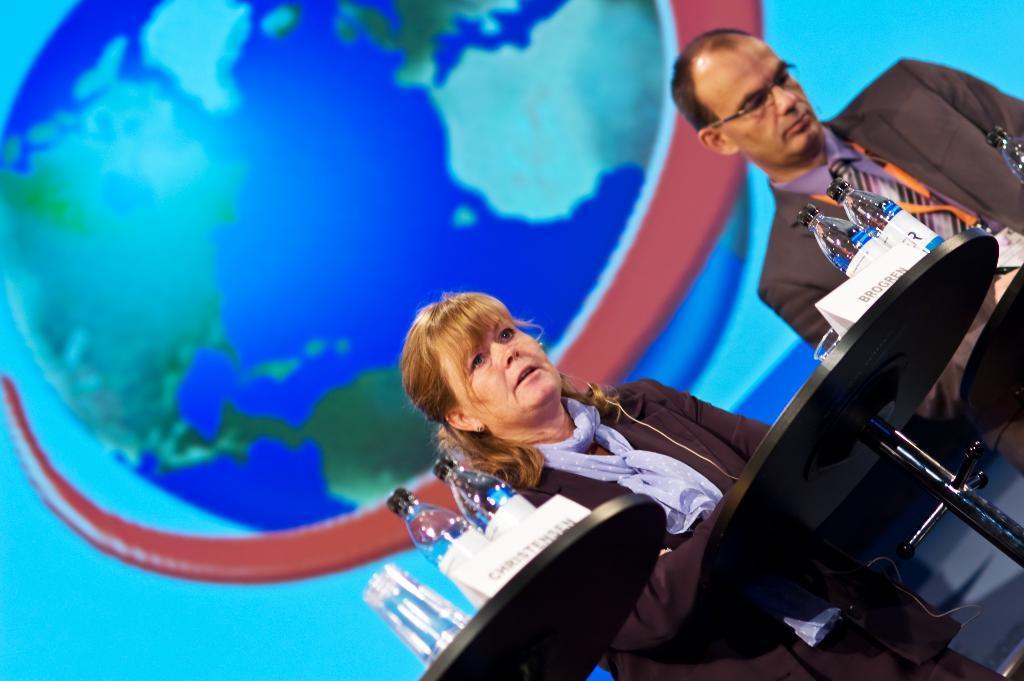Please provide a concise description of this image. In this image I can see two persons are standing in front of the table and on the table I can see bottles, boards and glasses. I can see the blue, green and red colored background. 